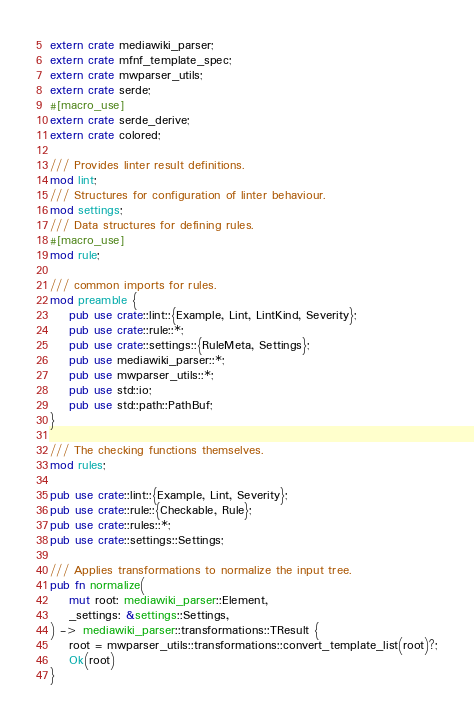Convert code to text. <code><loc_0><loc_0><loc_500><loc_500><_Rust_>extern crate mediawiki_parser;
extern crate mfnf_template_spec;
extern crate mwparser_utils;
extern crate serde;
#[macro_use]
extern crate serde_derive;
extern crate colored;

/// Provides linter result definitions.
mod lint;
/// Structures for configuration of linter behaviour.
mod settings;
/// Data structures for defining rules.
#[macro_use]
mod rule;

/// common imports for rules.
mod preamble {
    pub use crate::lint::{Example, Lint, LintKind, Severity};
    pub use crate::rule::*;
    pub use crate::settings::{RuleMeta, Settings};
    pub use mediawiki_parser::*;
    pub use mwparser_utils::*;
    pub use std::io;
    pub use std::path::PathBuf;
}

/// The checking functions themselves.
mod rules;

pub use crate::lint::{Example, Lint, Severity};
pub use crate::rule::{Checkable, Rule};
pub use crate::rules::*;
pub use crate::settings::Settings;

/// Applies transformations to normalize the input tree.
pub fn normalize(
    mut root: mediawiki_parser::Element,
    _settings: &settings::Settings,
) -> mediawiki_parser::transformations::TResult {
    root = mwparser_utils::transformations::convert_template_list(root)?;
    Ok(root)
}
</code> 